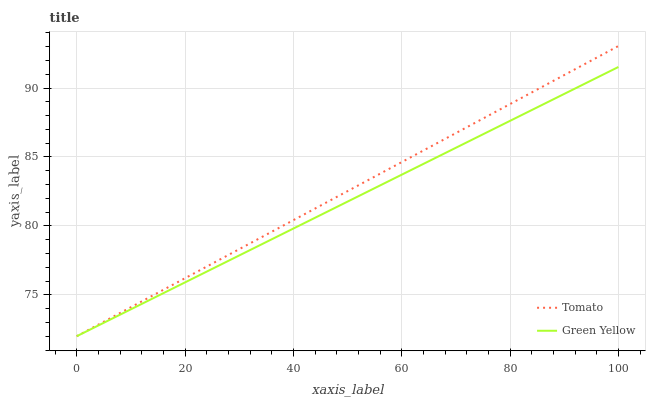Does Green Yellow have the minimum area under the curve?
Answer yes or no. Yes. Does Tomato have the maximum area under the curve?
Answer yes or no. Yes. Does Green Yellow have the maximum area under the curve?
Answer yes or no. No. Is Tomato the smoothest?
Answer yes or no. Yes. Is Green Yellow the roughest?
Answer yes or no. Yes. Is Green Yellow the smoothest?
Answer yes or no. No. Does Green Yellow have the highest value?
Answer yes or no. No. 